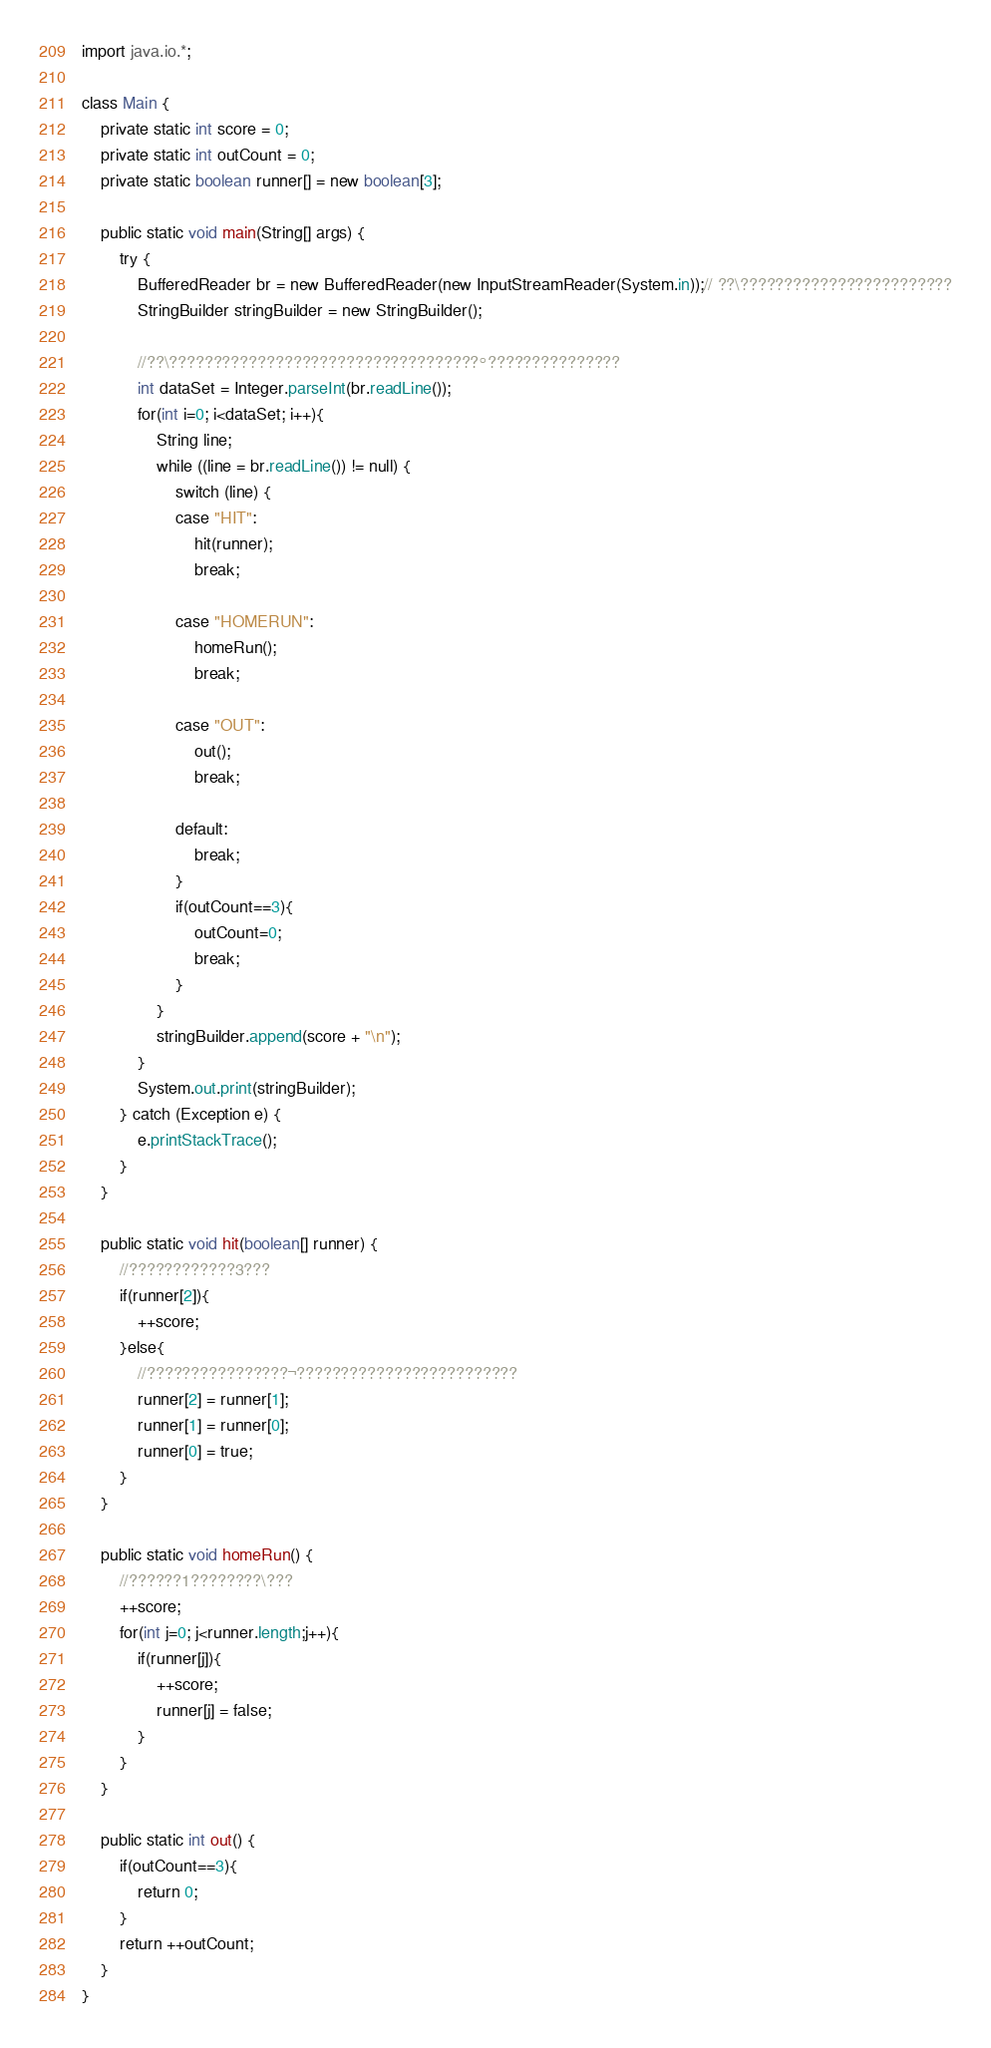Convert code to text. <code><loc_0><loc_0><loc_500><loc_500><_Java_>import java.io.*;

class Main {
	private static int score = 0;
    private static int outCount = 0;
    private static boolean runner[] = new boolean[3];
	
	public static void main(String[] args) {
    	try {
            BufferedReader br = new BufferedReader(new InputStreamReader(System.in));// ??\????????????????????????
            StringBuilder stringBuilder = new StringBuilder();
            
            //??\???????????????????????????????????°???????????????
            int dataSet = Integer.parseInt(br.readLine());
            for(int i=0; i<dataSet; i++){
	            String line;
	            while ((line = br.readLine()) != null) {
	            	switch (line) {
					case "HIT":
						hit(runner);
						break;
					
					case "HOMERUN":
						homeRun();
						break;
					
					case "OUT":
						out();
						break;
					
					default:
						break;
					}
	            	if(outCount==3){
	            		outCount=0;
	            		break;
	            	}
	            }
	            stringBuilder.append(score + "\n");
            }
            System.out.print(stringBuilder);
        } catch (Exception e) {
            e.printStackTrace();
        }
    }

    public static void hit(boolean[] runner) {
    	//????????????3???
    	if(runner[2]){
    		++score;
    	}else{
    		//????????????????¬?????????????????????????
    		runner[2] = runner[1];
    		runner[1] = runner[0];
    		runner[0] = true;
    	}
    }
    
    public static void homeRun() {
    	//??????1????????\???
    	++score;
    	for(int j=0; j<runner.length;j++){
    		if(runner[j]){
    			++score;
    			runner[j] = false;
    		}
    	}
    }
    
    public static int out() {
		if(outCount==3){
    		return 0;
    	}
		return ++outCount;
    }
}</code> 